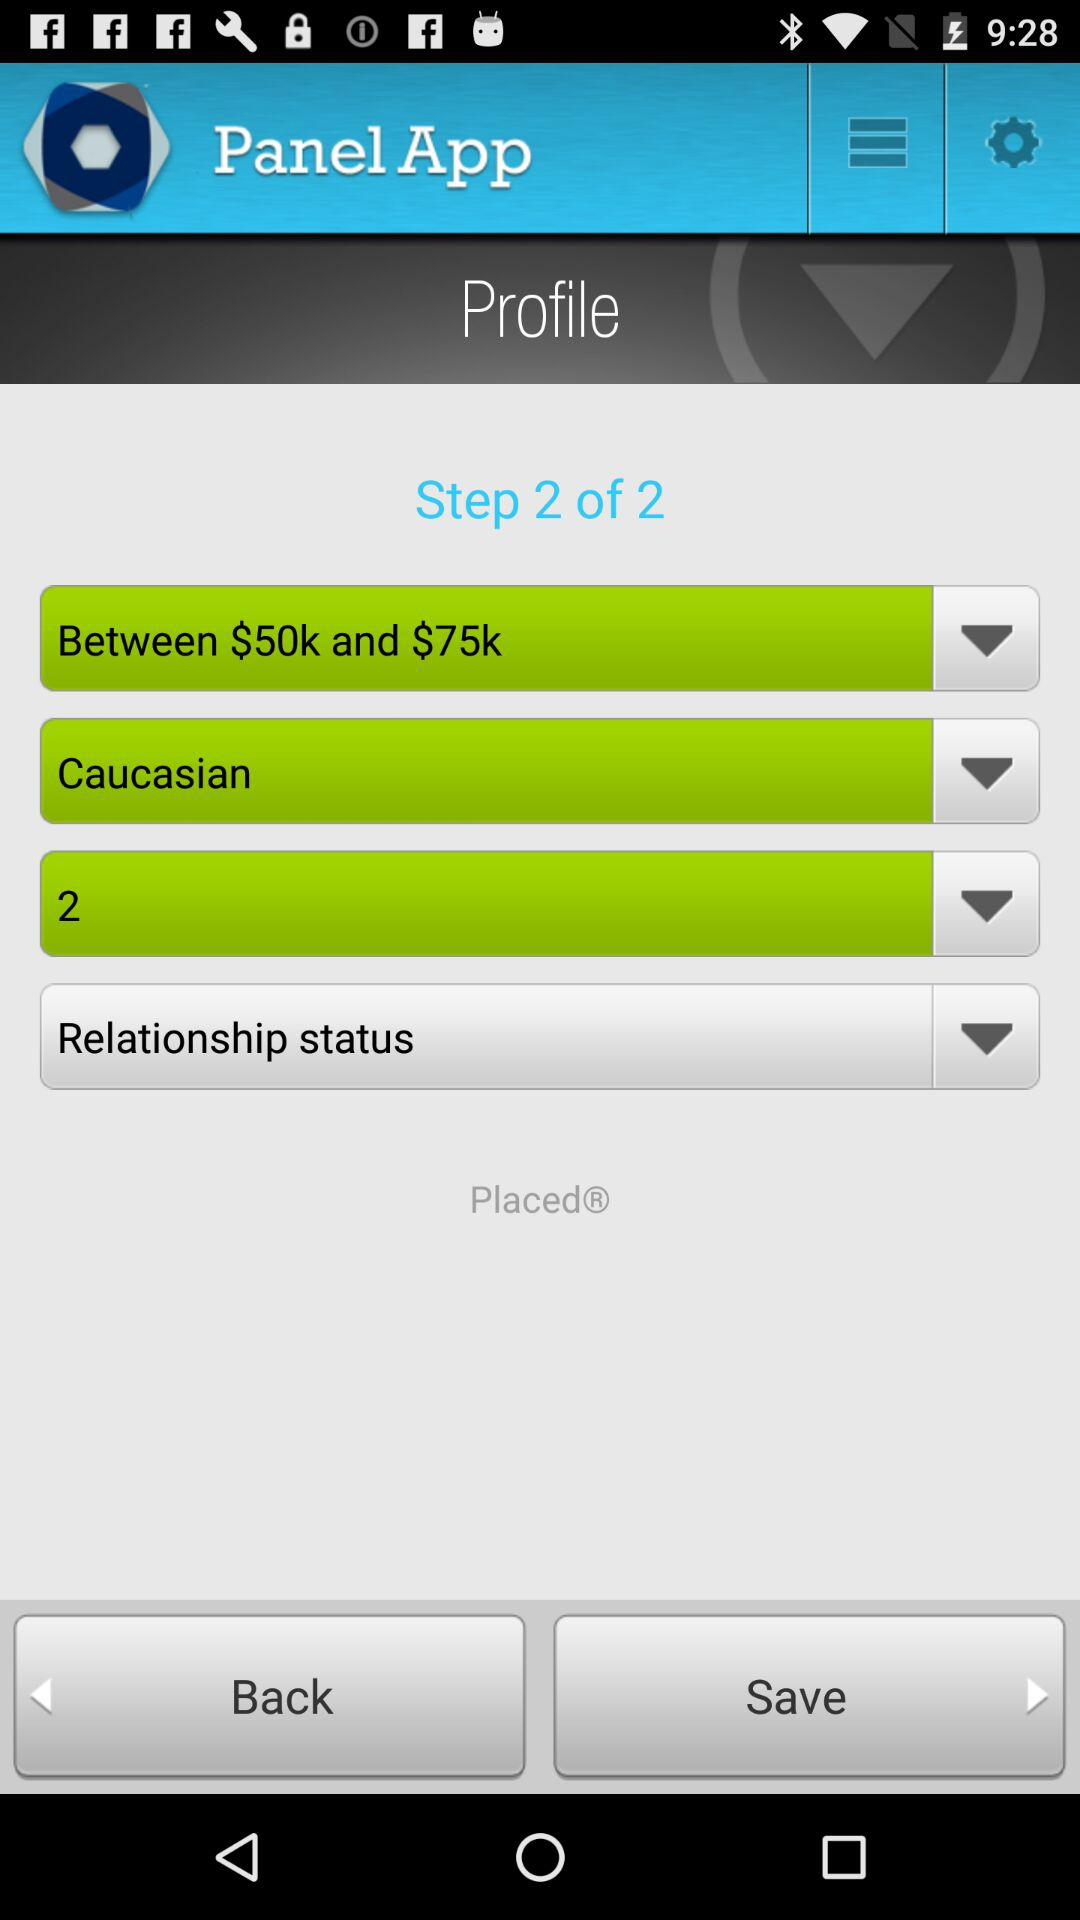What are the total number of steps? The total number of steps is 2. 